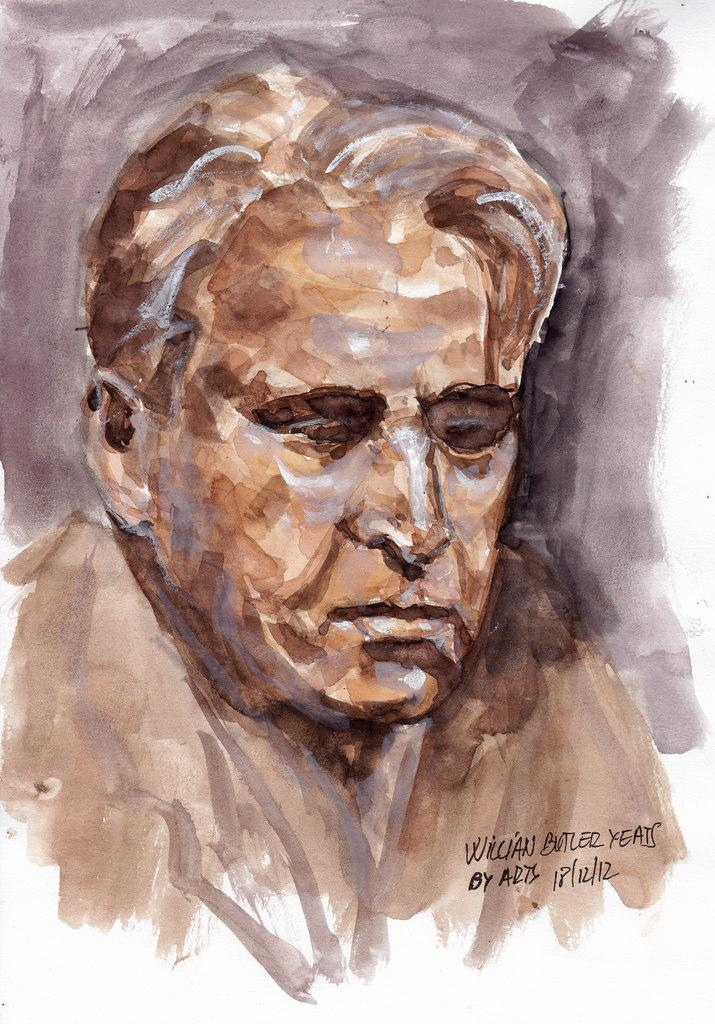What is the main subject of the image? There is a painting in the image. What can be seen in the painting? There is a person depicted in the painting. Where is the text located in the image? The text is on the right side of the image. How many chickens are depicted in the painting? There are no chickens depicted in the painting; it features a person. Can you describe the organization of the painting? The painting itself does not have an organization, as it is a static image. 